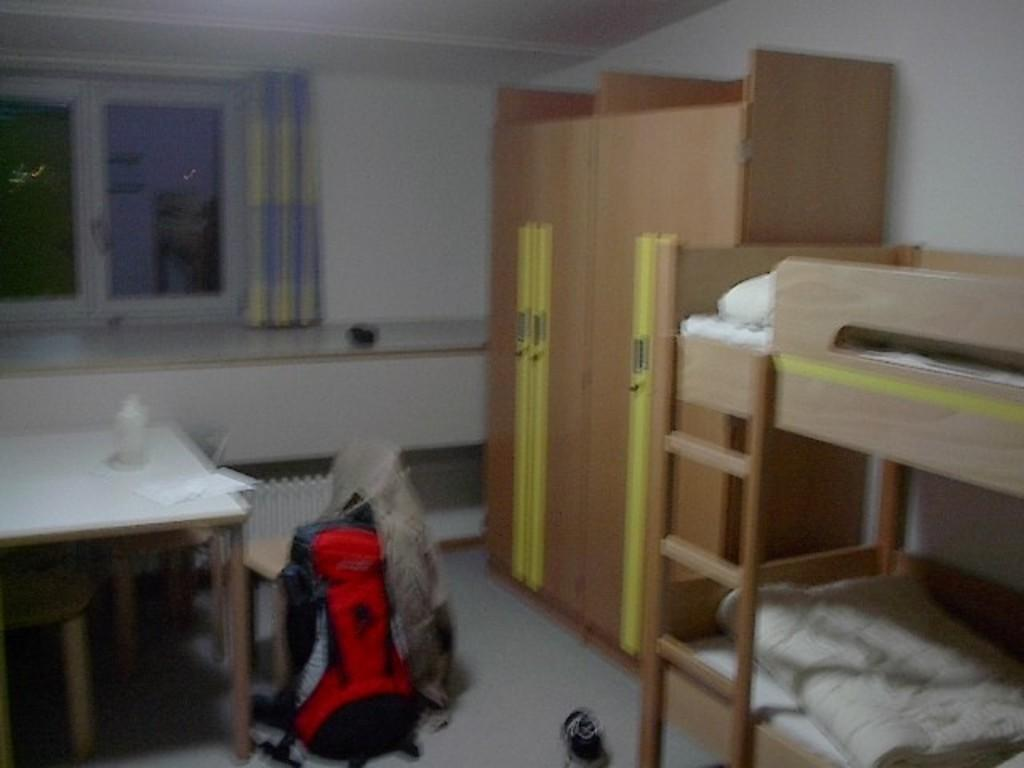What type of furniture is present in the image? There is a table and chairs in the image. What personal item can be seen in the image? There is a bag in the image. What type of sleeping arrangement is visible in the image? There is a bed in the image. What type of footwear is present in the image? There is a shoe in the image. What type of storage furniture is present in the image? There is a cupboard in the image. What items are on the table in the image? There is a paper and a bottle on the table in the image. What architectural features can be seen in the background of the image? There is a wall, a window, and a curtain associated with the window in the background of the image. What type of bread is present on the table in the image? There is no bread present on the table in the image. What season is depicted in the image? The image does not depict a specific season, as there are no seasonal indicators present. 